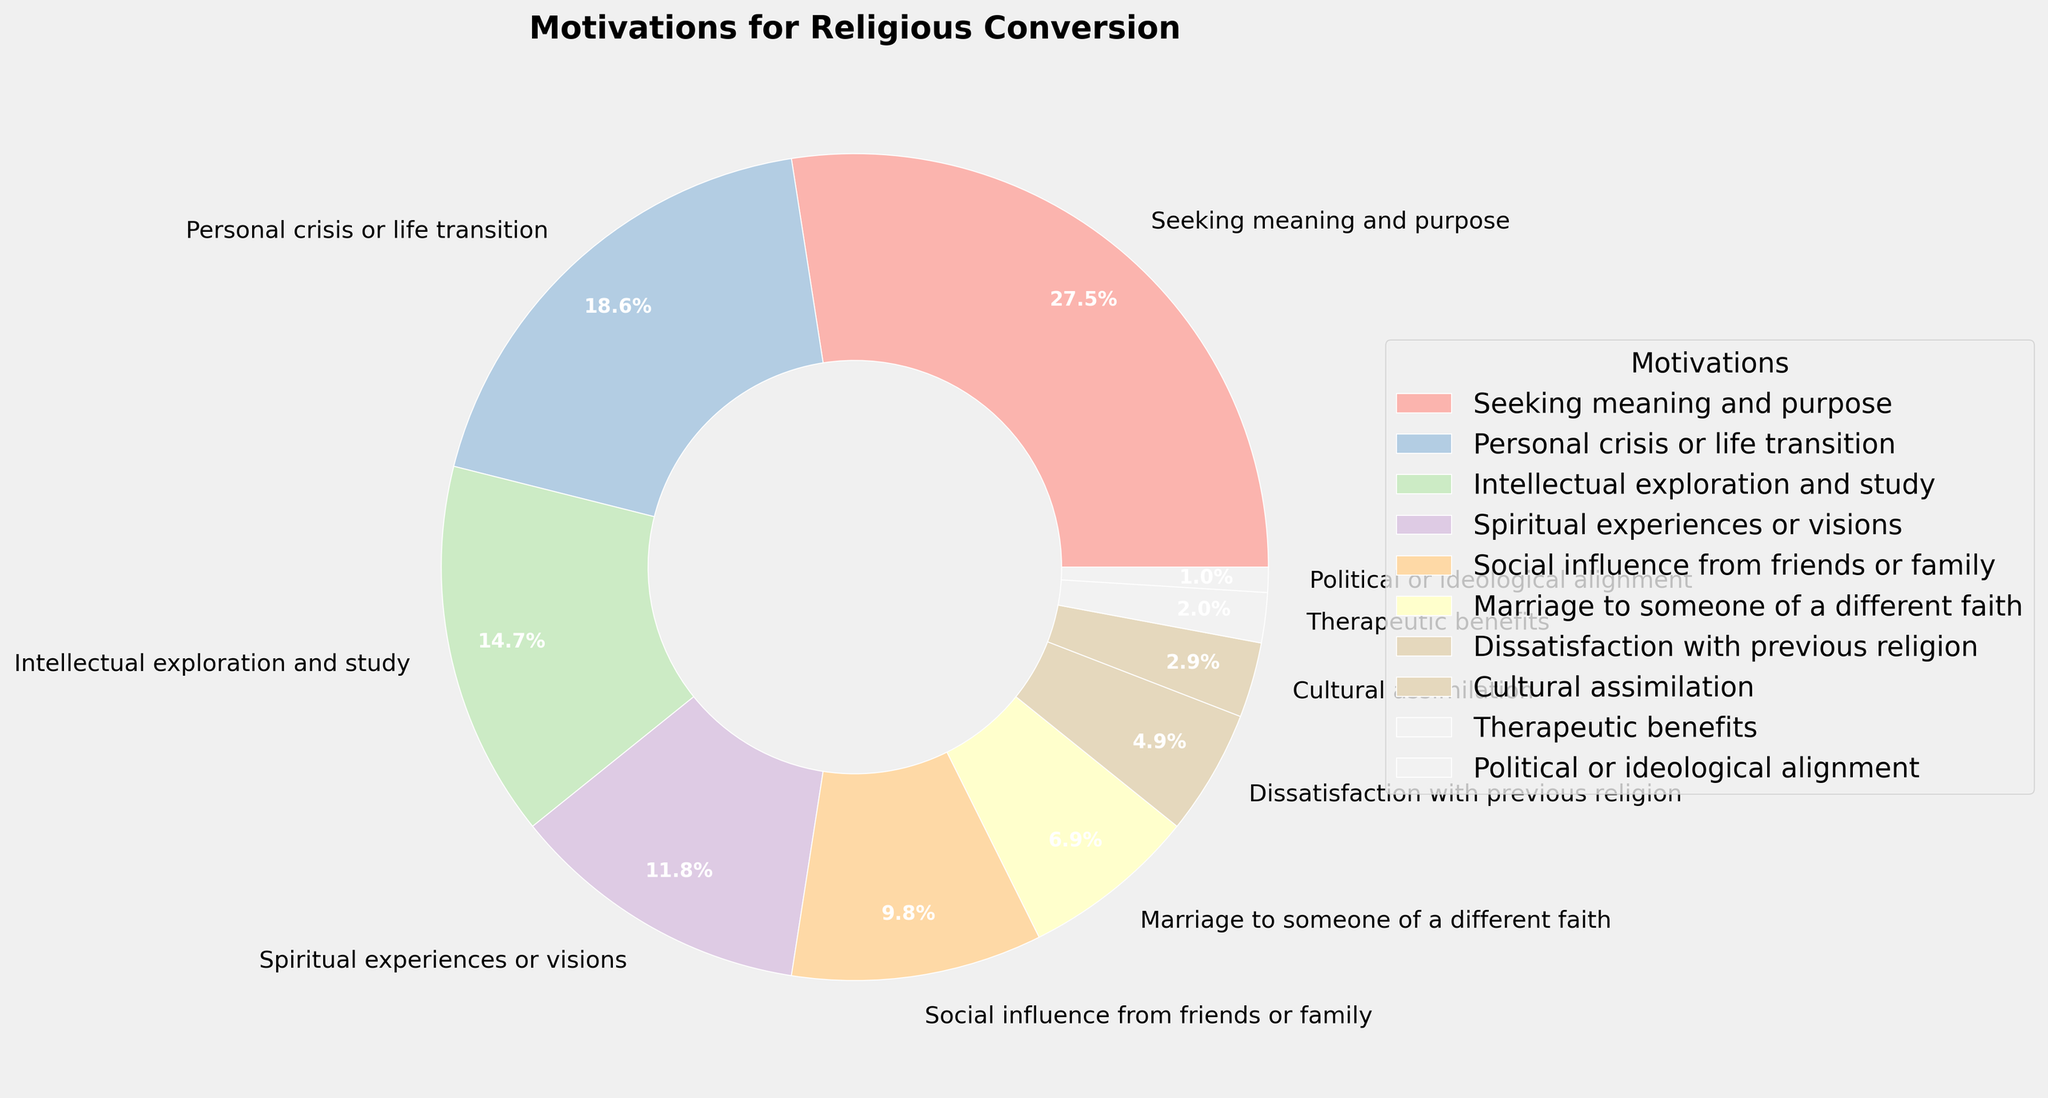Which motivation has the highest percentage? Inspect the pie chart and identify the segment with the largest area. Look for the label that corresponds to this segment.
Answer: Seeking meaning and purpose Which motivations have percentages less than 5%? Scan through the pie chart labels and their associated percentages to find those that are less than 5%.
Answer: Dissatisfaction with previous religion, Cultural assimilation, Therapeutic benefits, Political or ideological alignment What is the combined percentage of "Social influence from friends or family" and "Marriage to someone of a different faith"? Locate the segments for "Social influence from friends or family" and "Marriage to someone of a different faith" and add their percentages together (10% + 7%).
Answer: 17% Which motivations contribute to more than 40% of conversions? Identify and sum the percentages of the top motivations until the total exceeds 40% (28% + 19% = 47%).
Answer: Seeking meaning and purpose, Personal crisis or life transition What is the difference in percentage between "Spiritual experiences or visions" and "Intellectual exploration and study"? Find the percentages for both motivations and subtract the smaller from the larger (15% - 12%).
Answer: 3% Which motivations have the same color shade in the chart? Observe the colors used for each segment in the pie chart, identify the segments that use the same color shade, and list those motivations.
Answer: Each motivation has a unique color shade; none have the same color Arrange the motivations with percentages greater than 10% in descending order. Extract and list the motivations with percentages greater than 10%, then sort them from highest to lowest (28%, 19%, 15%, 12%).
Answer: Seeking meaning and purpose, Personal crisis or life transition, Intellectual exploration and study, Spiritual experiences or visions What is the average percentage of motivations categorized under family or social influence? Add the percentages of relevant motivations ("Social influence from friends or family" and "Marriage to someone of a different faith") and divide by two ((10% + 7%) / 2).
Answer: 8.5% Which segment in the pie chart has the smallest area? Identify the smallest segment based on its proportional size in the pie chart and its associated label.
Answer: Political or ideological alignment 